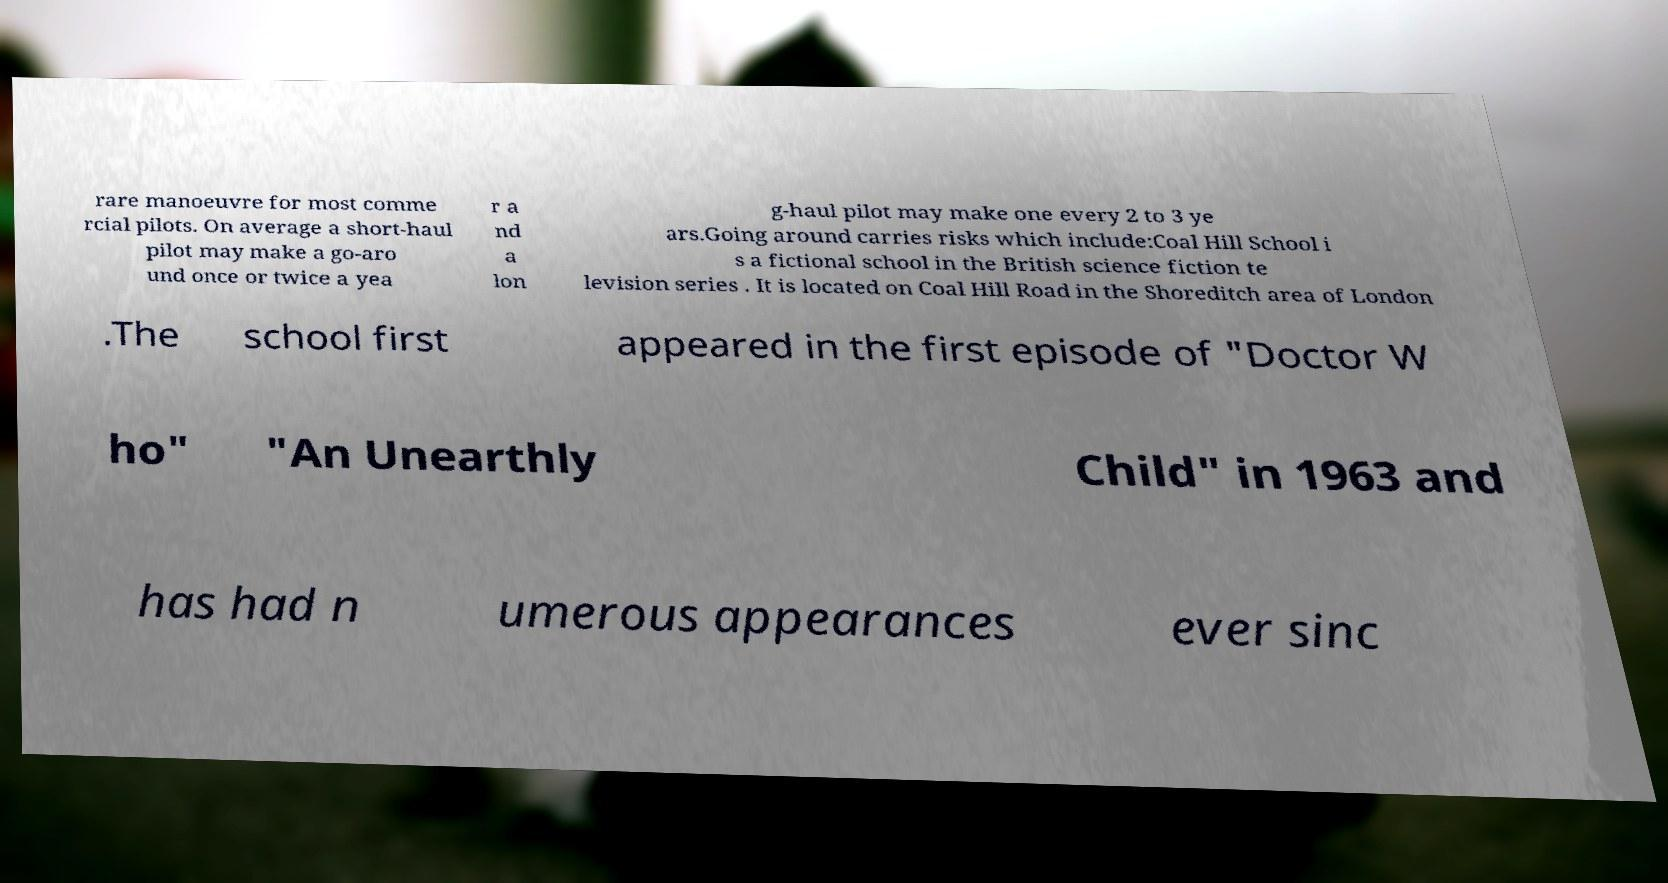Could you extract and type out the text from this image? rare manoeuvre for most comme rcial pilots. On average a short-haul pilot may make a go-aro und once or twice a yea r a nd a lon g-haul pilot may make one every 2 to 3 ye ars.Going around carries risks which include:Coal Hill School i s a fictional school in the British science fiction te levision series . It is located on Coal Hill Road in the Shoreditch area of London .The school first appeared in the first episode of "Doctor W ho" "An Unearthly Child" in 1963 and has had n umerous appearances ever sinc 